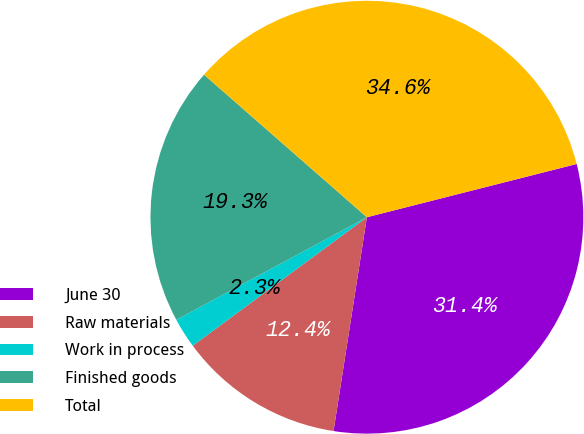Convert chart to OTSL. <chart><loc_0><loc_0><loc_500><loc_500><pie_chart><fcel>June 30<fcel>Raw materials<fcel>Work in process<fcel>Finished goods<fcel>Total<nl><fcel>31.42%<fcel>12.42%<fcel>2.26%<fcel>19.3%<fcel>34.6%<nl></chart> 